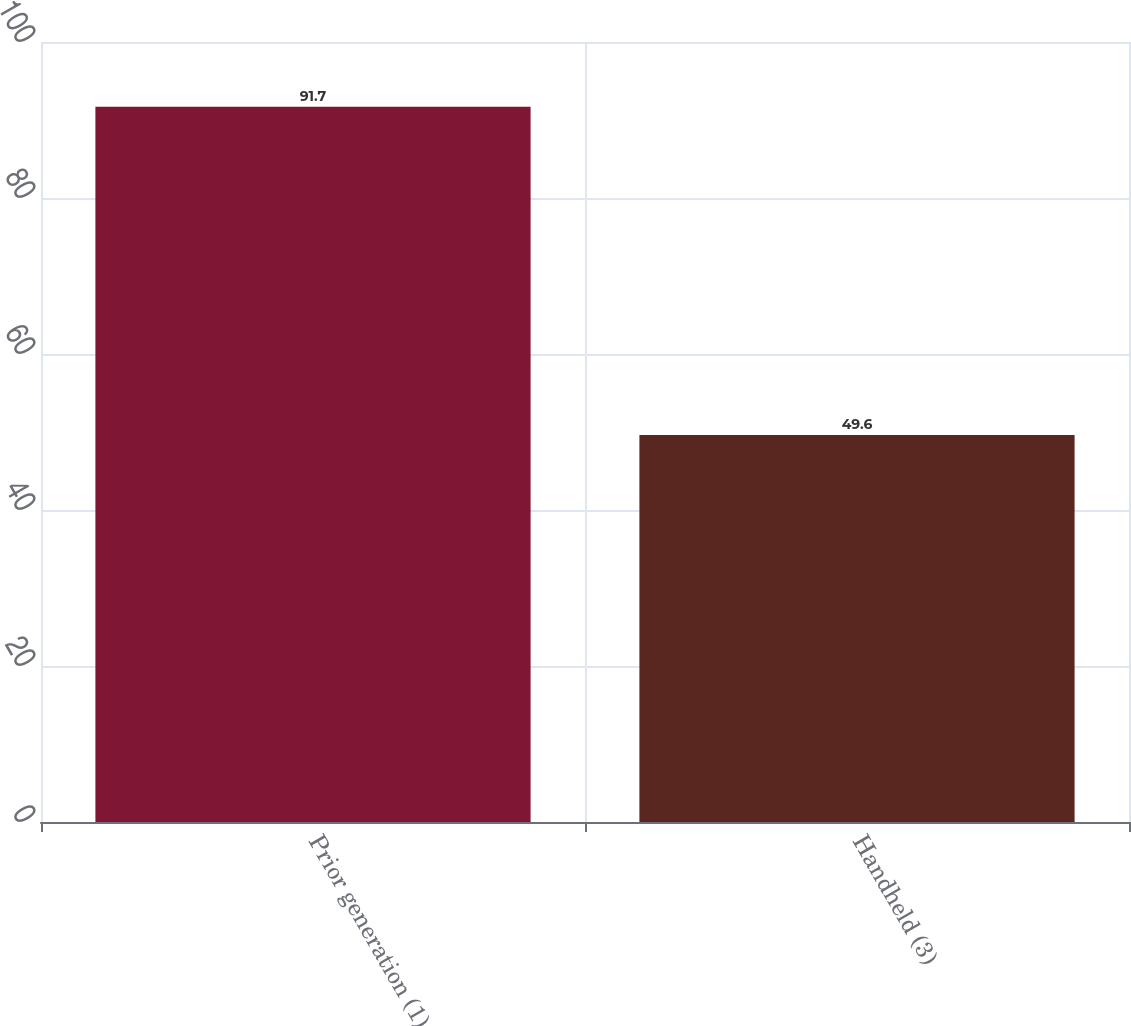Convert chart. <chart><loc_0><loc_0><loc_500><loc_500><bar_chart><fcel>Prior generation (1)<fcel>Handheld (3)<nl><fcel>91.7<fcel>49.6<nl></chart> 